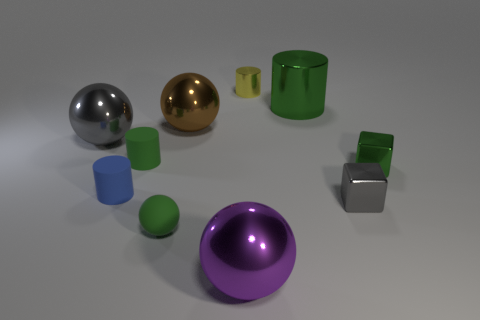Subtract all small balls. How many balls are left? 3 Subtract all green cubes. How many green cylinders are left? 2 Subtract all yellow cylinders. How many cylinders are left? 3 Subtract all blocks. How many objects are left? 8 Add 8 brown metallic things. How many brown metallic things are left? 9 Add 8 small green matte cylinders. How many small green matte cylinders exist? 9 Subtract 1 gray cubes. How many objects are left? 9 Subtract all purple cylinders. Subtract all red blocks. How many cylinders are left? 4 Subtract all yellow things. Subtract all tiny spheres. How many objects are left? 8 